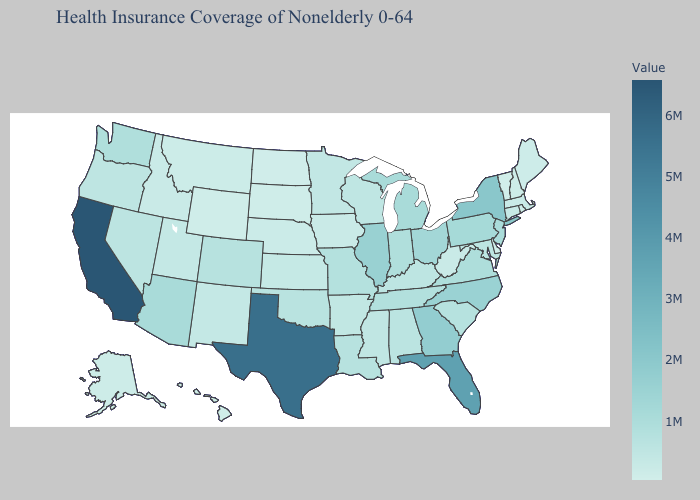Does Vermont have the lowest value in the USA?
Short answer required. Yes. Among the states that border Delaware , which have the highest value?
Be succinct. Pennsylvania. Which states have the lowest value in the USA?
Answer briefly. Vermont. Is the legend a continuous bar?
Write a very short answer. Yes. 